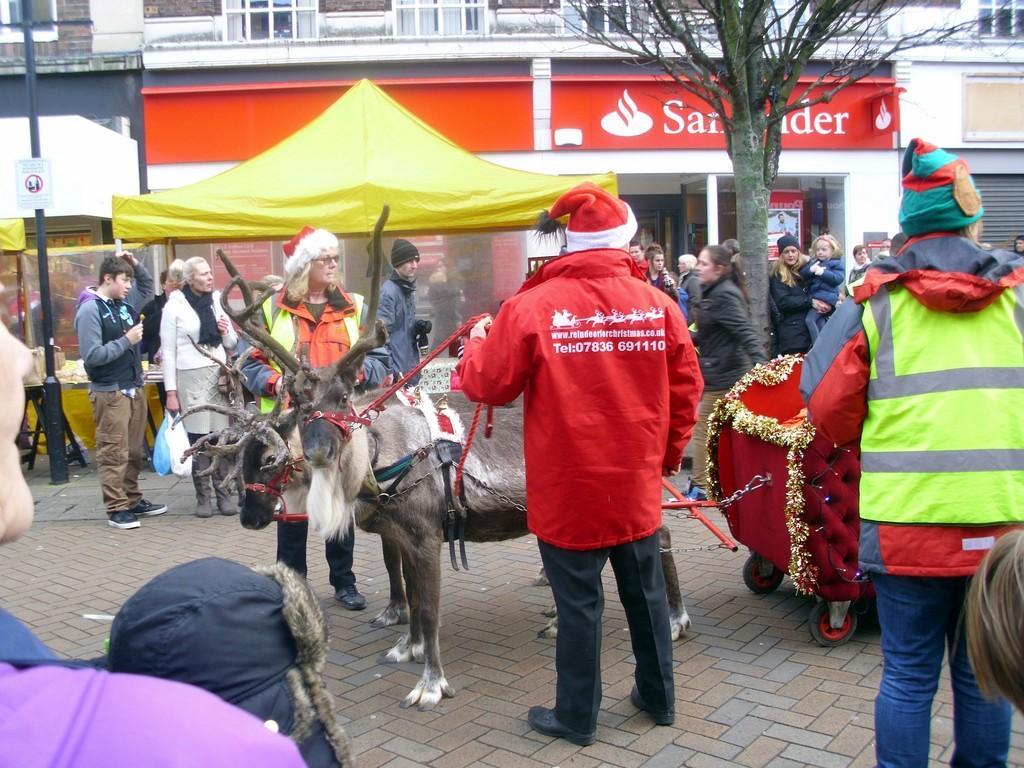In one or two sentences, can you explain what this image depicts? In this image two animals are tied to a cart. Person wearing a red jacket is having a cap. He is holding a rope which is tied to the animal. Behind the animal there is a person wearing a cap. A person wearing a scarf is holding two covers in his hand. There are few persons standing on the cobblestone path. There is a tent, beside there is a tree. Left side there are few persons. Background there is a building. Left side there is a pole having a board attached to it. 